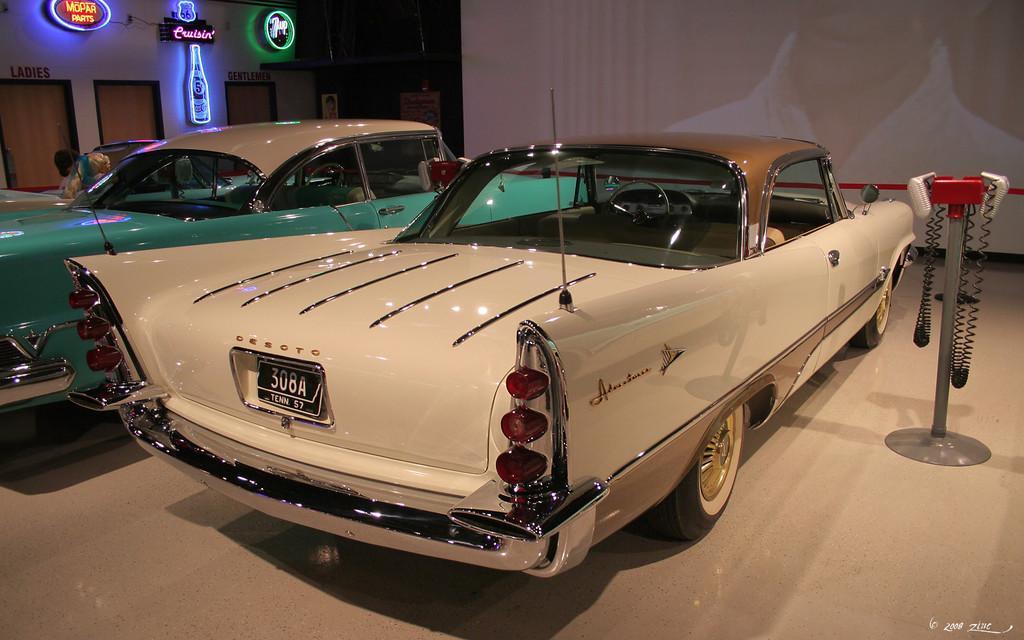How would you summarize this image in a sentence or two? In this image we can able to see two cars one is of cream in color, and the other one is of green in color, and we can see a screen in front of those cars, we can see two bathrooms one belongs to men, and the other one belongs to ladies, and we can see three boards over here, and there is a machine beside car. 